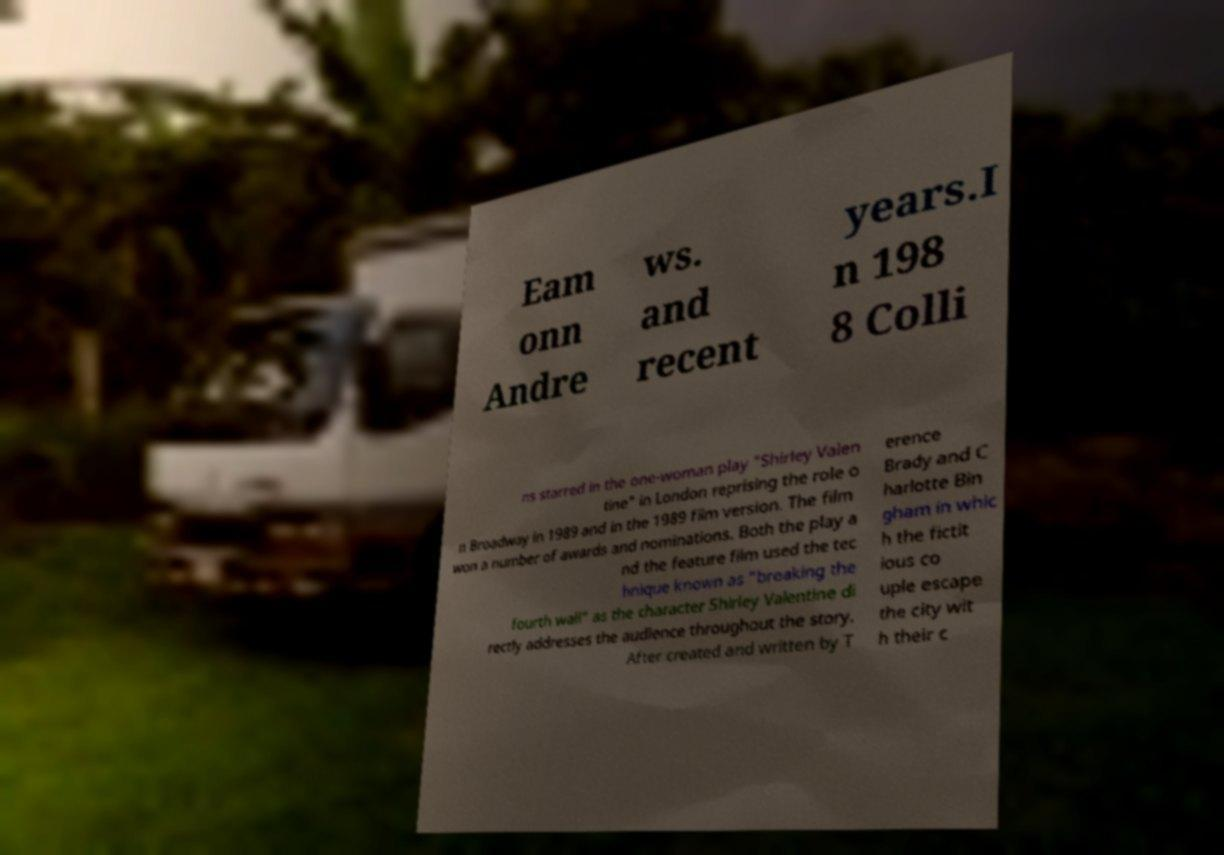Can you read and provide the text displayed in the image?This photo seems to have some interesting text. Can you extract and type it out for me? Eam onn Andre ws. and recent years.I n 198 8 Colli ns starred in the one-woman play "Shirley Valen tine" in London reprising the role o n Broadway in 1989 and in the 1989 film version. The film won a number of awards and nominations. Both the play a nd the feature film used the tec hnique known as "breaking the fourth wall" as the character Shirley Valentine di rectly addresses the audience throughout the story. After created and written by T erence Brady and C harlotte Bin gham in whic h the fictit ious co uple escape the city wit h their c 